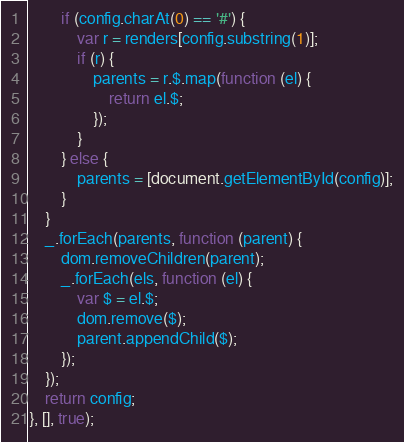<code> <loc_0><loc_0><loc_500><loc_500><_JavaScript_>        if (config.charAt(0) == '#') {
            var r = renders[config.substring(1)];
            if (r) {
                parents = r.$.map(function (el) {
                    return el.$;
                });
            }
        } else {
            parents = [document.getElementById(config)];
        }
    }
    _.forEach(parents, function (parent) {
        dom.removeChildren(parent);
        _.forEach(els, function (el) {
            var $ = el.$;
            dom.remove($);
            parent.appendChild($);
        });
    });
    return config;
}, [], true);</code> 